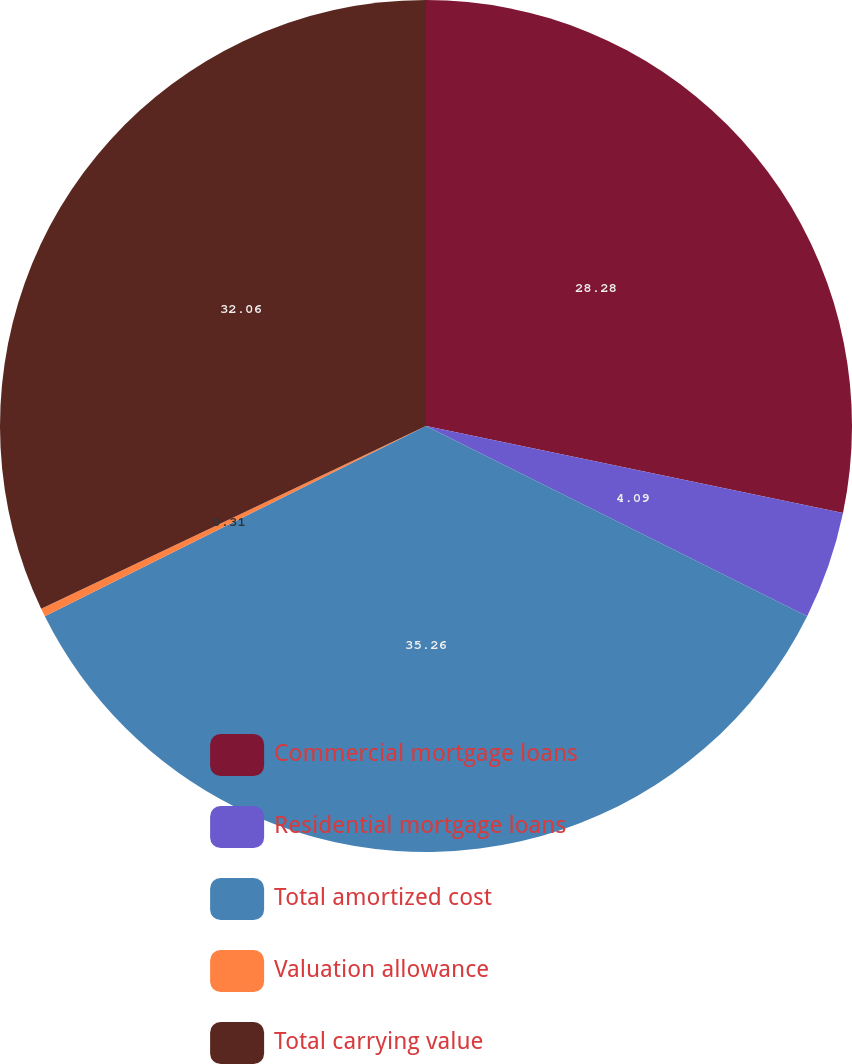Convert chart. <chart><loc_0><loc_0><loc_500><loc_500><pie_chart><fcel>Commercial mortgage loans<fcel>Residential mortgage loans<fcel>Total amortized cost<fcel>Valuation allowance<fcel>Total carrying value<nl><fcel>28.28%<fcel>4.09%<fcel>35.27%<fcel>0.31%<fcel>32.06%<nl></chart> 